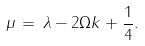<formula> <loc_0><loc_0><loc_500><loc_500>\mu \, = \, \lambda - 2 \Omega k + \frac { 1 } { 4 } .</formula> 